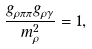Convert formula to latex. <formula><loc_0><loc_0><loc_500><loc_500>\frac { g _ { \rho \pi \pi } g _ { \rho \gamma } } { m ^ { 2 } _ { \rho } } = 1 ,</formula> 